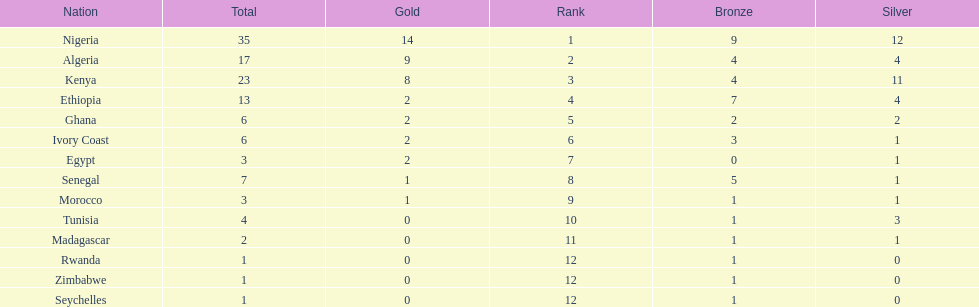Which nations have won only one medal? Rwanda, Zimbabwe, Seychelles. 